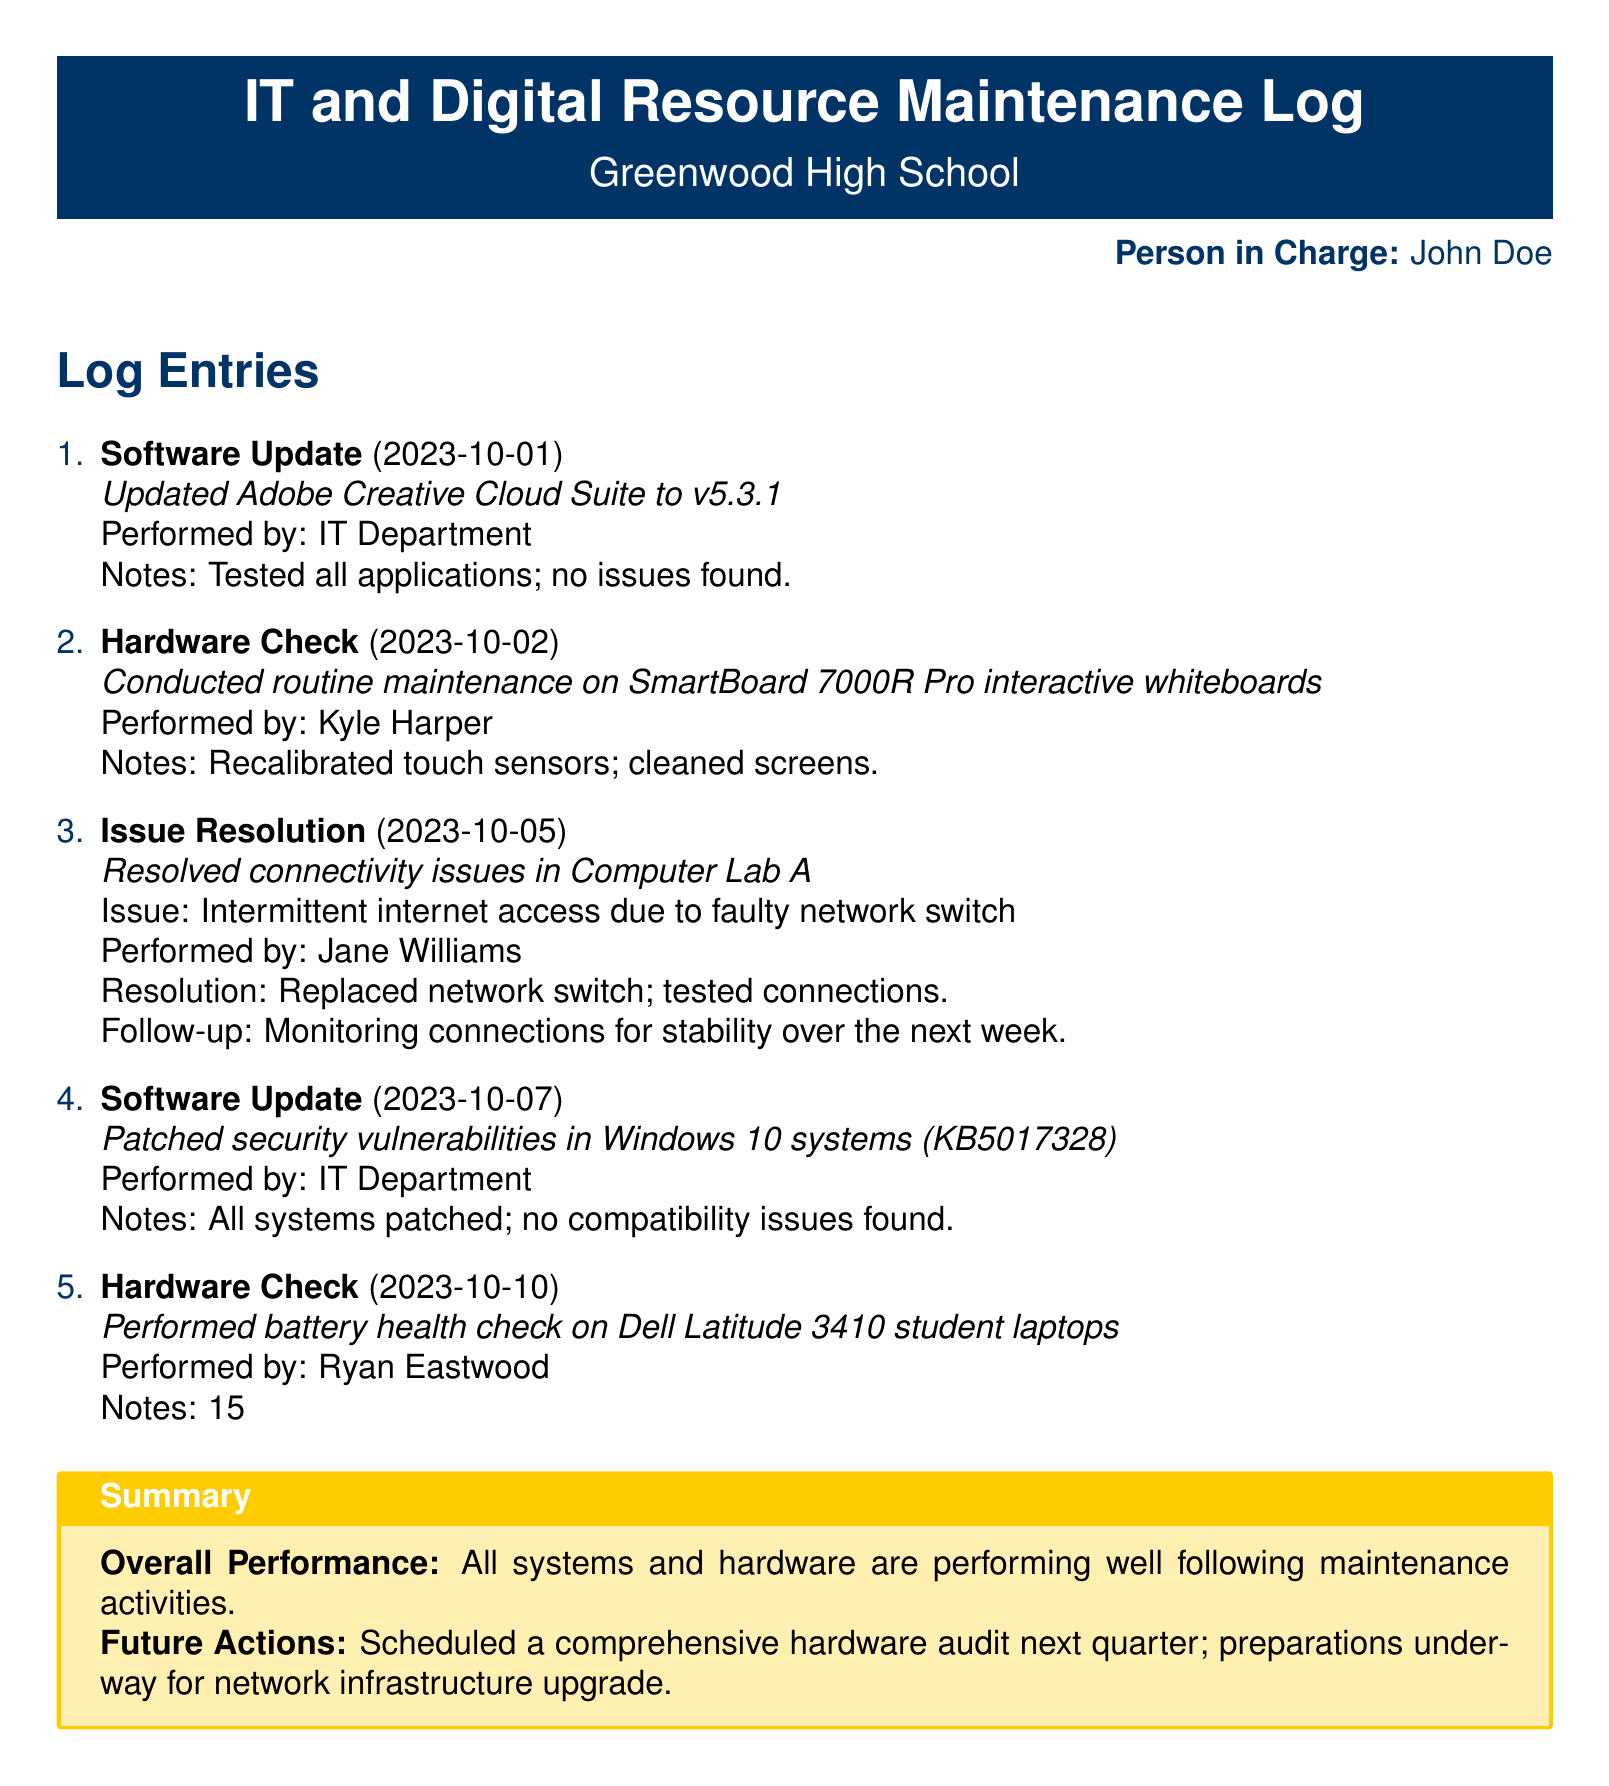what is the name of the person in charge? The name of the person in charge is mentioned in the document, listed as John Doe.
Answer: John Doe when was the last software update performed? The last software update was recorded in the log with a specific date, which is October 7, 2023.
Answer: 2023-10-07 how many laptops showed reduced battery capacity? The number of laptops with reduced battery capacity is stated in the notes of the hardware check.
Answer: 15% who performed the maintenance on the SmartBoard? The individual who conducted the maintenance on the SmartBoard is identified in the document as Kyle Harper.
Answer: Kyle Harper what issue was resolved in Computer Lab A? The document specifies that the issue in Computer Lab A involved intermittent internet access due to a faulty network switch.
Answer: Faulty network switch what is the overall performance summary of the systems? The document provides an overall performance summary that indicates the condition of systems and hardware post-maintenance.
Answer: Performing well how many software updates are listed in the log? The total number of software updates can be determined by counting the relevant entries in the maintenance log.
Answer: 2 what is scheduled for the next quarter? The document mentions a specific maintenance activity that is scheduled for the next quarter.
Answer: Comprehensive hardware audit 